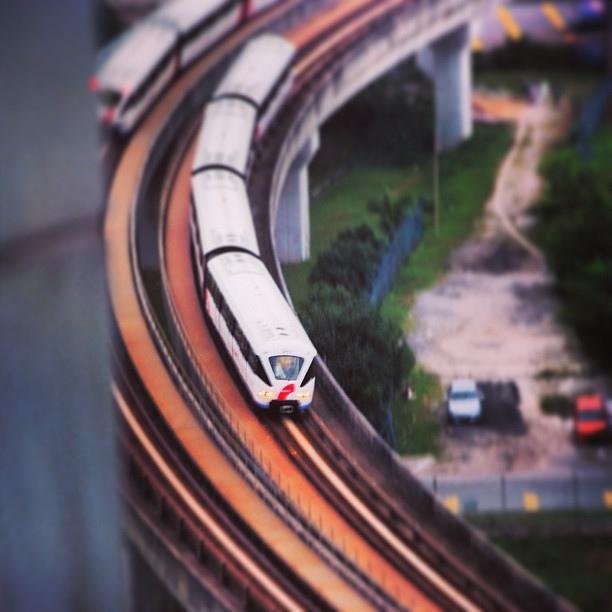Is this a real train?
Answer briefly. No. How many red cars are there?
Short answer required. 1. What is at the bottom?
Short answer required. Cars. 